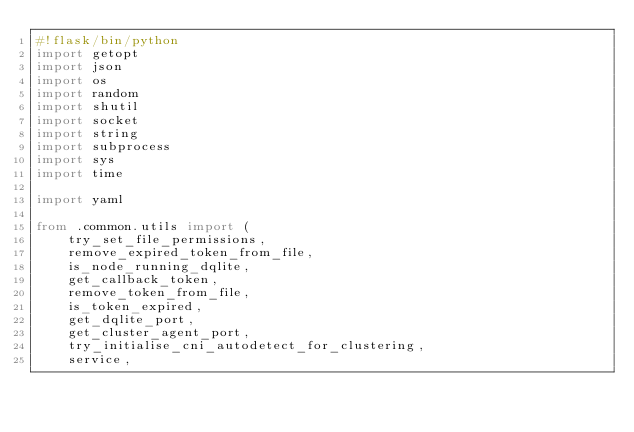<code> <loc_0><loc_0><loc_500><loc_500><_Python_>#!flask/bin/python
import getopt
import json
import os
import random
import shutil
import socket
import string
import subprocess
import sys
import time

import yaml

from .common.utils import (
    try_set_file_permissions,
    remove_expired_token_from_file,
    is_node_running_dqlite,
    get_callback_token,
    remove_token_from_file,
    is_token_expired,
    get_dqlite_port,
    get_cluster_agent_port,
    try_initialise_cni_autodetect_for_clustering,
    service,</code> 